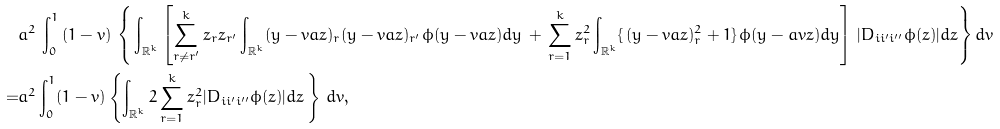<formula> <loc_0><loc_0><loc_500><loc_500>& a ^ { 2 } \, \int _ { 0 } ^ { 1 } \, ( 1 - v ) \, \left \{ \, \int _ { { \mathbb { R } } ^ { k } } \left [ \sum _ { r \neq r ^ { \prime } } ^ { k } z _ { r } z _ { r ^ { \prime } } \int _ { { \mathbb { R } } ^ { k } } ( y - v a z ) _ { r } ( y - v a z ) _ { r ^ { \prime } } \phi ( y - v a z ) d y \, + \, \sum _ { r = 1 } ^ { k } z _ { r } ^ { 2 } \int _ { { \mathbb { R } } ^ { k } } \{ \, ( y - v a z ) _ { r } ^ { 2 } + 1 \} \, \phi ( y - a v z ) d y \right ] \, | D _ { i i ^ { \prime } i ^ { \prime \prime } } \phi ( z ) | d z \right \} d v \\ = & a ^ { 2 } \int _ { 0 } ^ { 1 } ( 1 - v ) \left \{ \int _ { { \mathbb { R } } ^ { k } } 2 \sum _ { r = 1 } ^ { k } z _ { r } ^ { 2 } | D _ { i i ^ { \prime } i ^ { \prime \prime } } \phi ( z ) | d z \, \right \} \, d v ,</formula> 